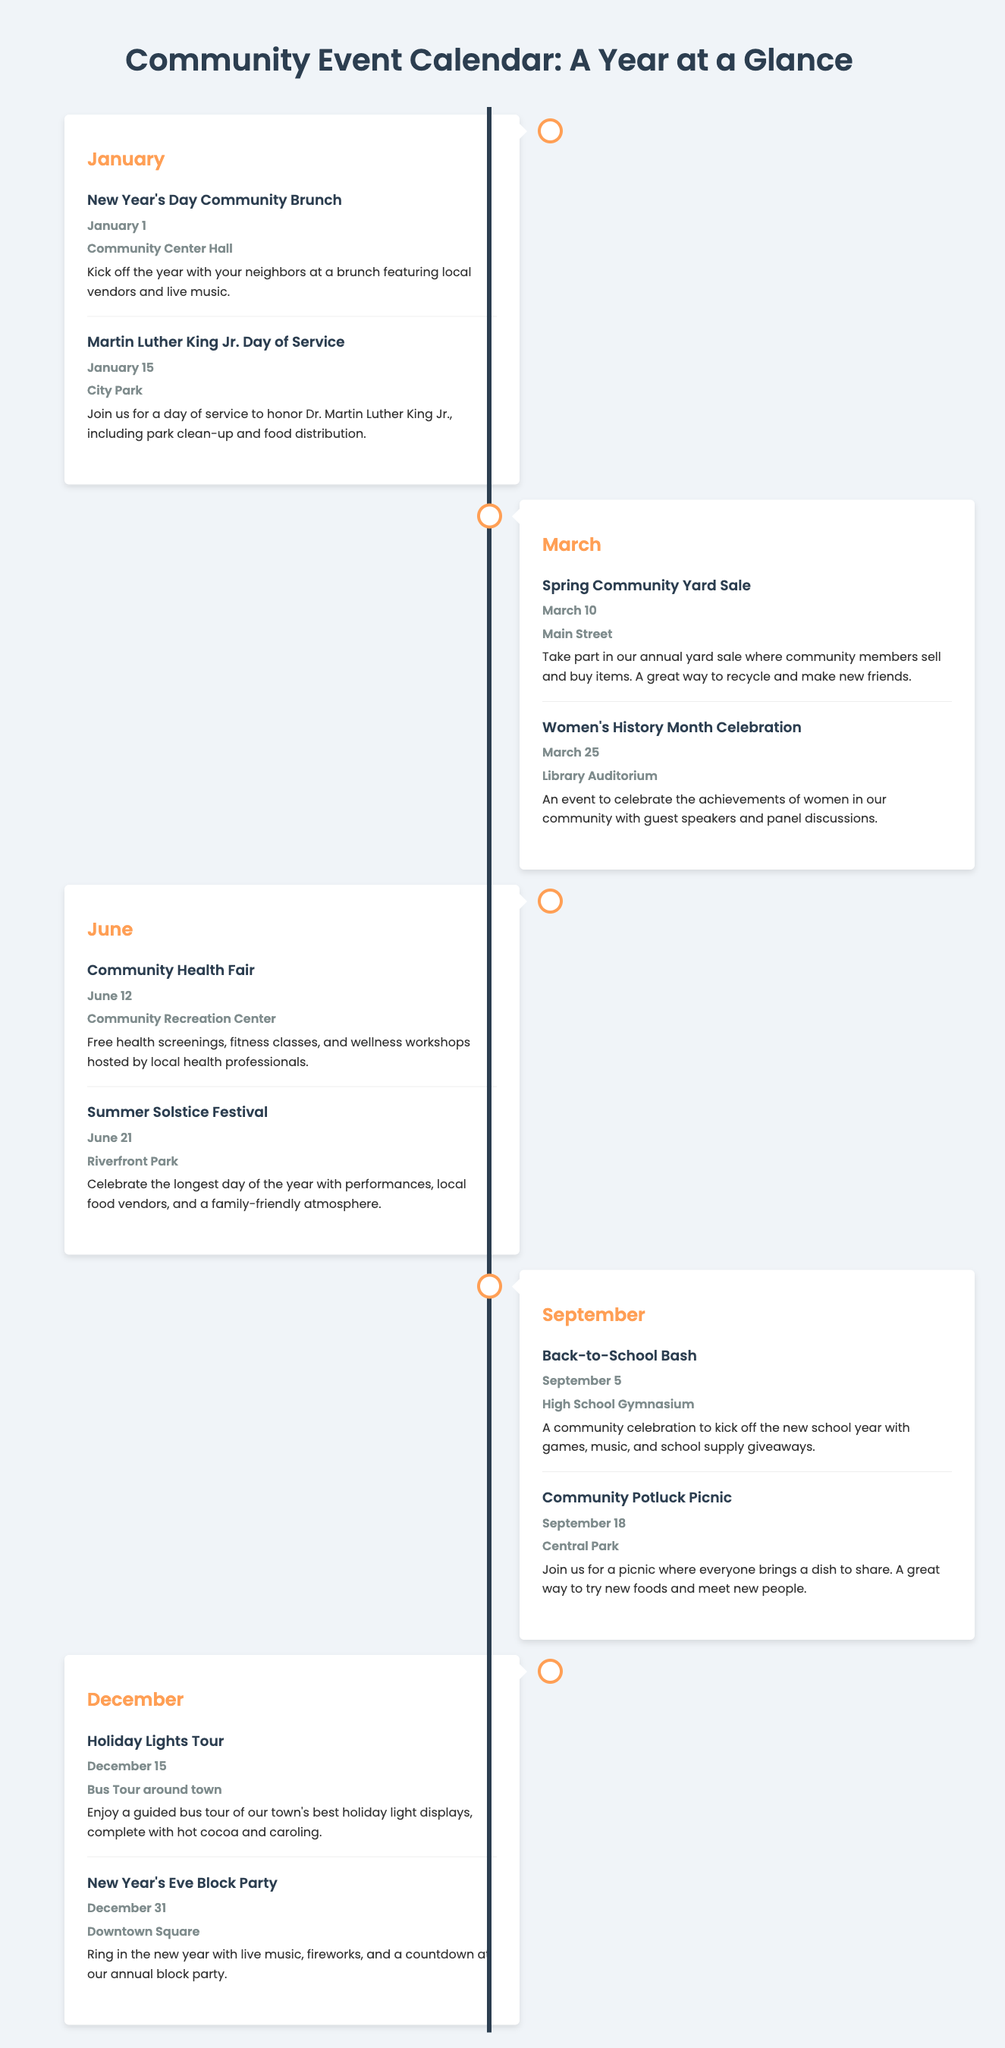what event occurs on January 1? The event listed for January 1 is the New Year's Day Community Brunch.
Answer: New Year's Day Community Brunch where is the March Women's History Month Celebration held? The location for this event is the Library Auditorium.
Answer: Library Auditorium how many events are listed for June? There are two events listed for June: Community Health Fair and Summer Solstice Festival.
Answer: 2 which month features a Back-to-School Bash? The Back-to-School Bash takes place in September.
Answer: September what is the date of the Holiday Lights Tour? The Holiday Lights Tour is scheduled for December 15.
Answer: December 15 which event focuses on community service and honors Dr. Martin Luther King Jr.? The event is the Martin Luther King Jr. Day of Service.
Answer: Martin Luther King Jr. Day of Service what is the primary activity at the Summer Solstice Festival? The primary activity at the Summer Solstice Festival includes performances, local food vendors, and a family-friendly atmosphere.
Answer: Performances and local food vendors which event takes place at the Community Center Hall? The event at the Community Center Hall is the New Year's Day Community Brunch.
Answer: New Year's Day Community Brunch what unique aspect is highlighted about the September Community Potluck Picnic? The unique aspect is that everyone brings a dish to share.
Answer: Everyone brings a dish to share 